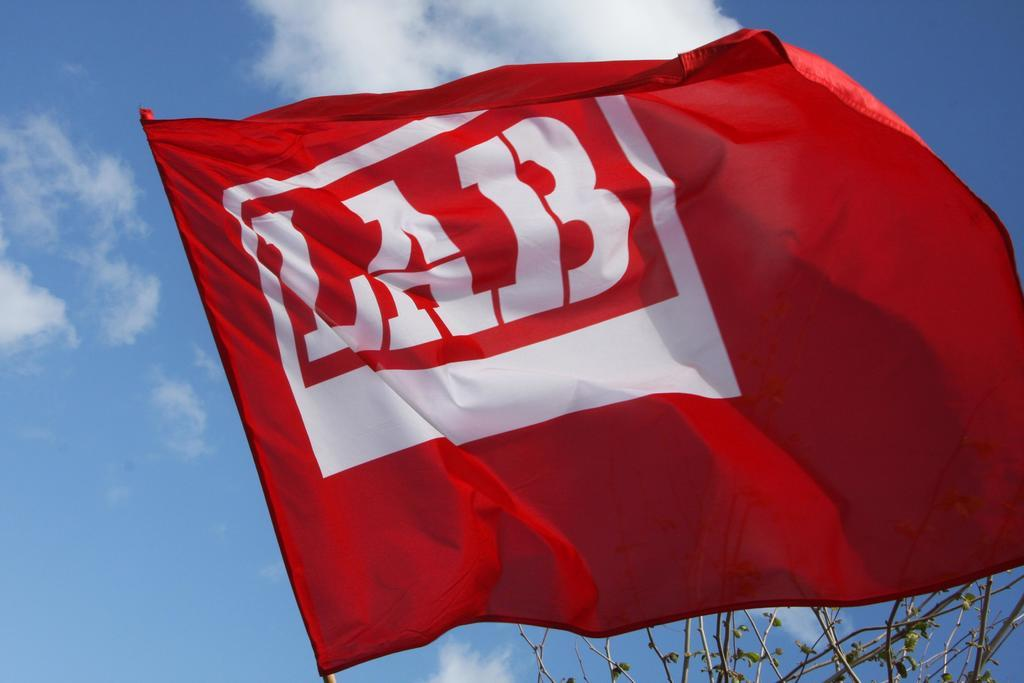What is the main object in the image? There is a red color flag in the image. Can you describe the flag in more detail? The flag has a white color text with a white color border. What can be seen in the background of the image? There is a tree in the background of the image. What is the color of the sky in the background? The sky in the background is blue, and there are clouds visible. How does the flag increase its size in the image? The flag does not increase its size in the image; it remains the same size throughout the picture. 